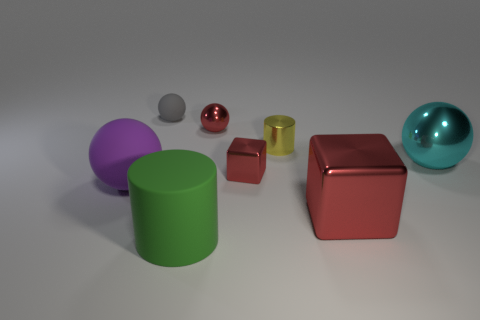Add 2 small cylinders. How many objects exist? 10 Subtract all cubes. How many objects are left? 6 Add 8 purple rubber objects. How many purple rubber objects are left? 9 Add 1 purple rubber things. How many purple rubber things exist? 2 Subtract 0 yellow cubes. How many objects are left? 8 Subtract all large cyan shiny objects. Subtract all cylinders. How many objects are left? 5 